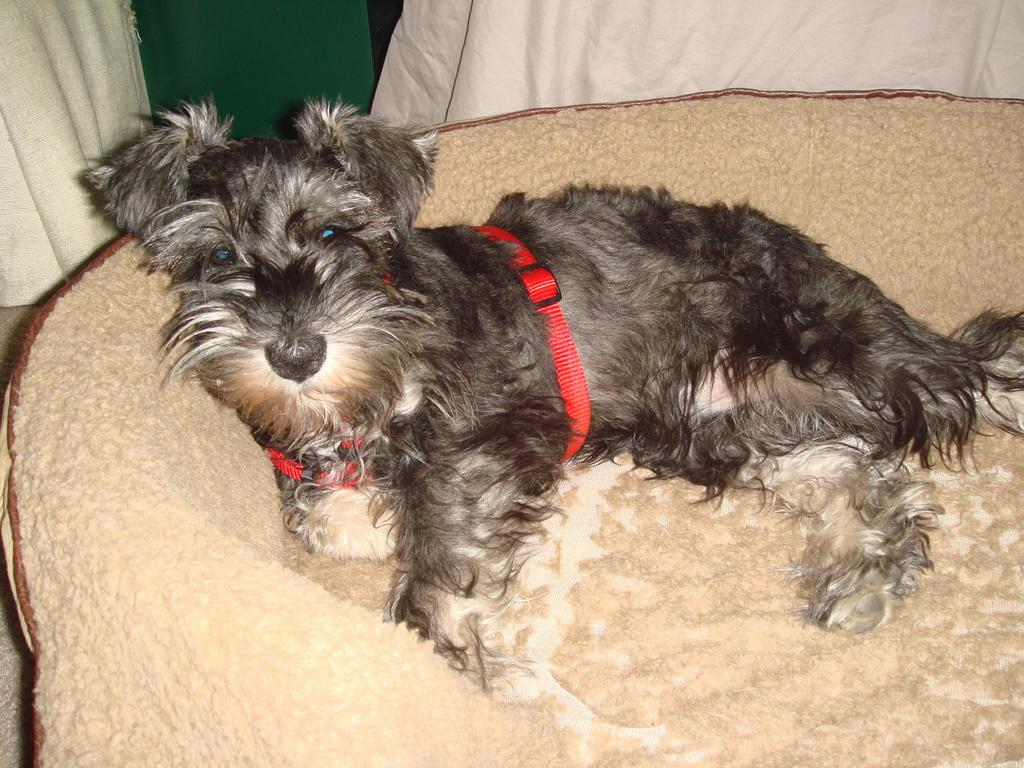What type of animal is in the image? There is a dog in the image. Can you describe the dog's color pattern? The dog has a white and black color pattern. What is the dog standing on in the image? The dog is on a cream-colored surface. What can be seen in the background of the image? There is a cloth in the background of the image. What colors are present on the cloth? The cloth has white and green colors. How many arms does the dog have in the image? Dogs do not have arms; they have four legs. The dog in the image has four legs, not arms. 